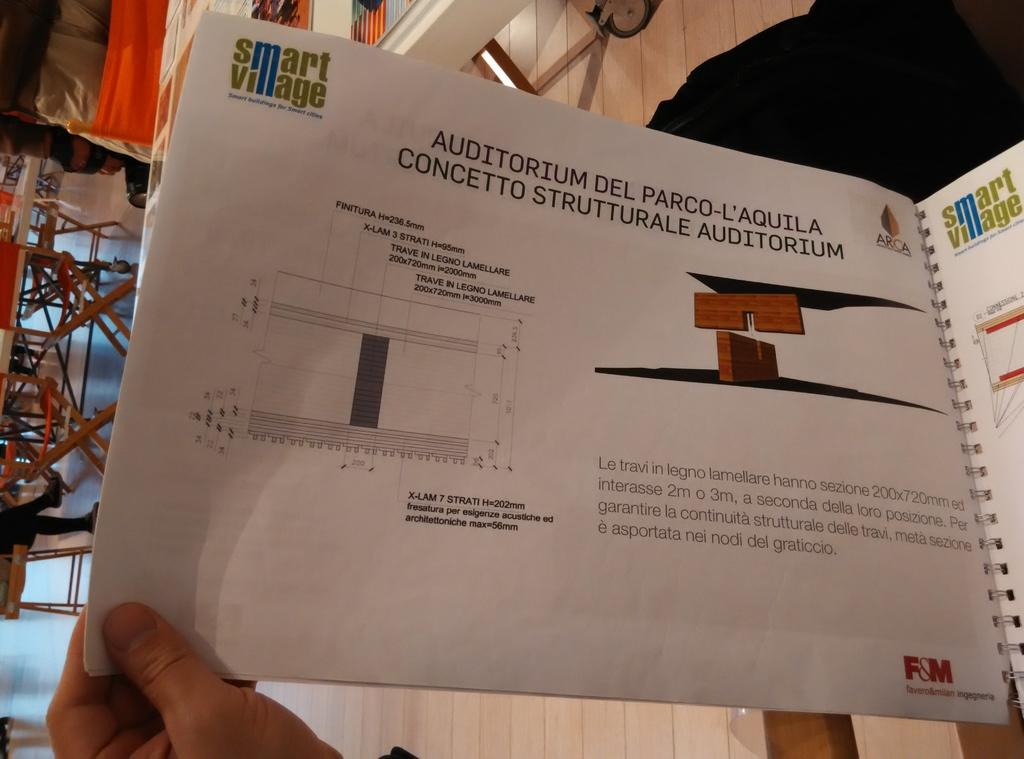Provide a one-sentence caption for the provided image. A page in a Smart Village booklet titled Auditorium Del Parco-L'Aquila Concetto Strutturale Auditorium. 